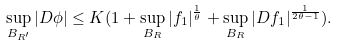<formula> <loc_0><loc_0><loc_500><loc_500>\sup _ { B _ { R ^ { \prime } } } | D \phi | \leq K ( 1 + \sup _ { B _ { R } } | f _ { 1 } | ^ { \frac { 1 } { \theta } } + \sup _ { B _ { R } } | D f _ { 1 } | ^ { \frac { 1 } { 2 \theta - 1 } } ) .</formula> 